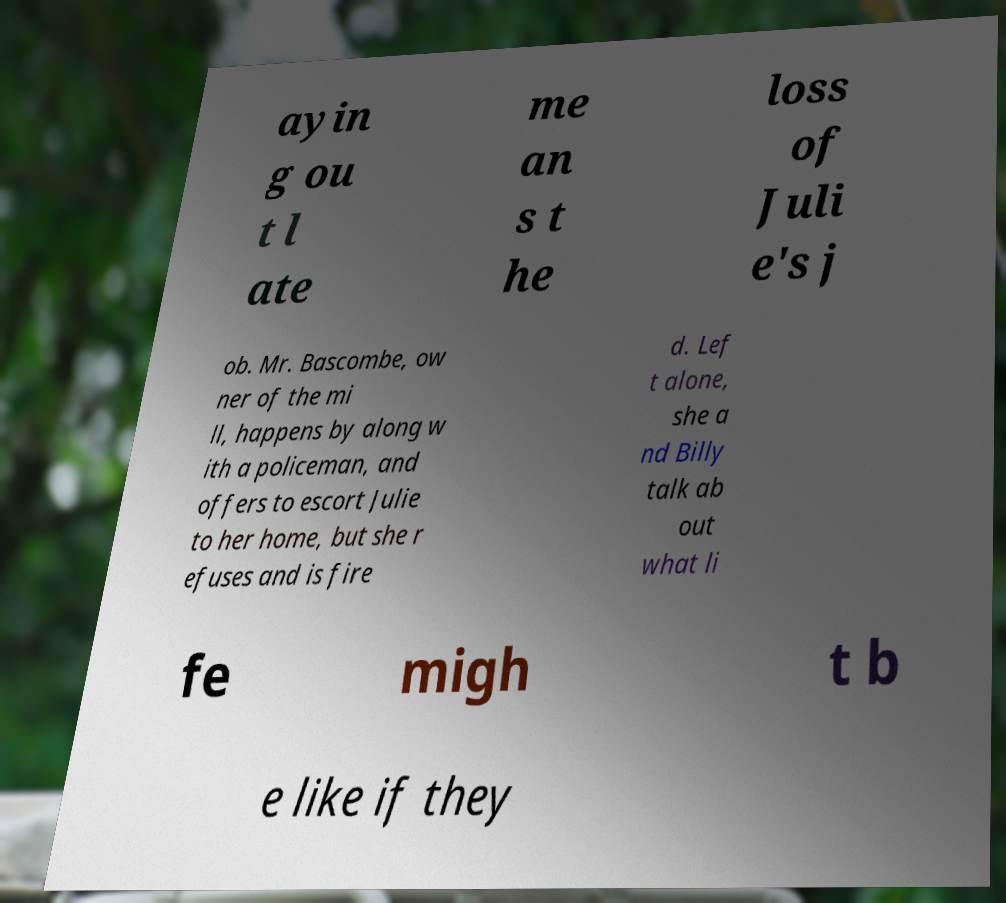Can you accurately transcribe the text from the provided image for me? ayin g ou t l ate me an s t he loss of Juli e's j ob. Mr. Bascombe, ow ner of the mi ll, happens by along w ith a policeman, and offers to escort Julie to her home, but she r efuses and is fire d. Lef t alone, she a nd Billy talk ab out what li fe migh t b e like if they 